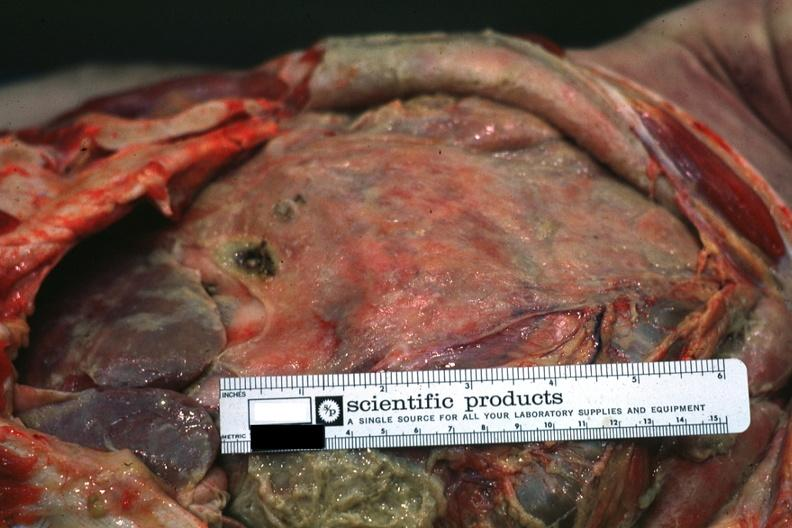s peritoneum present?
Answer the question using a single word or phrase. Yes 